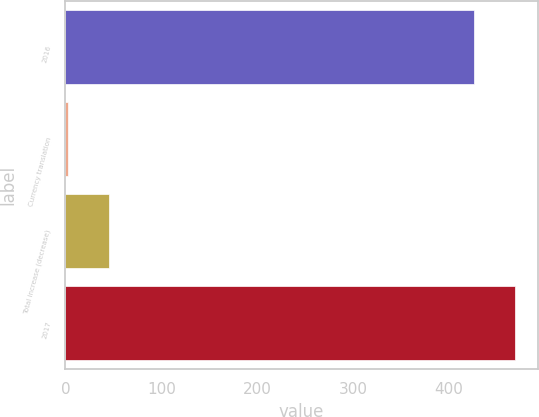Convert chart. <chart><loc_0><loc_0><loc_500><loc_500><bar_chart><fcel>2016<fcel>Currency translation<fcel>Total increase (decrease)<fcel>2017<nl><fcel>426.2<fcel>2.7<fcel>45.54<fcel>469.04<nl></chart> 